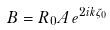<formula> <loc_0><loc_0><loc_500><loc_500>B & = R _ { 0 } A \, e ^ { 2 i k \zeta _ { 0 } }</formula> 